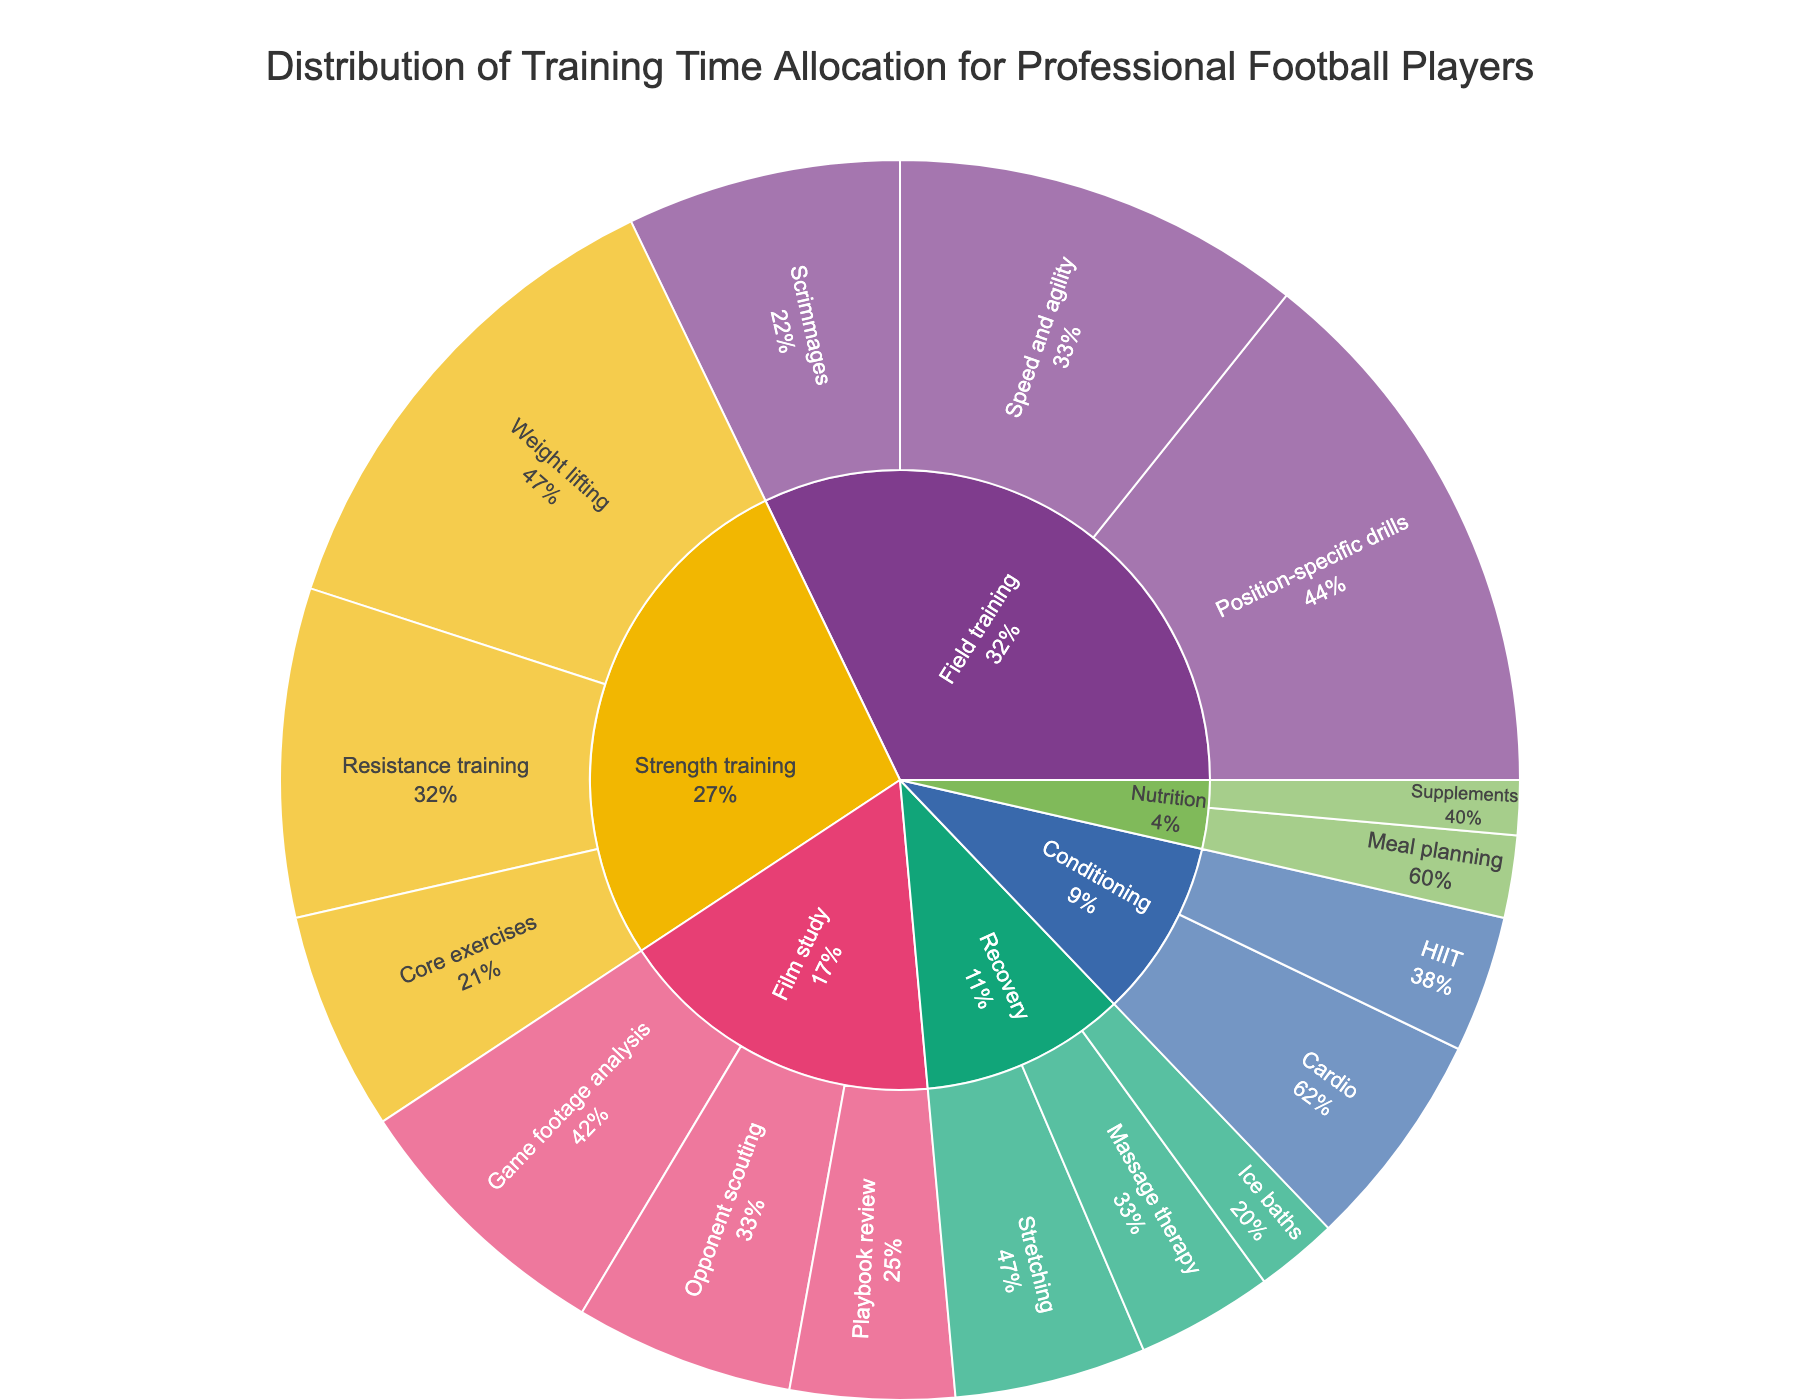What's the largest category in the sunburst plot? Look for the category with the highest summed value. Field training has three subcategories summing up to 45.
Answer: Field training How much time is allocated to Strength training? Add the values of Weight lifting, Resistance training, and Core exercises under Strength training: 18 + 12 + 8 = 38.
Answer: 38 Which subcategory has the smallest time allocation? Compare all the subcategories and identify the smallest value. Ice baths have a value of 3.
Answer: Ice baths Which category encompasses the most subcategories? Count the subcategories within each main category. Both Strength training and Film study have three subcategories each.
Answer: Strength training, Film study What percentage of Field training is allocated to Speed and agility? Speed and agility has a value of 15, and Field training sums to 45. Calculate the percentage: (15/45) * 100 = 33.33%.
Answer: 33.33% Which subcategory under Film study has the highest allocation of time? Identify and compare the values for subcategories within Film study. Game footage analysis has a value of 10.
Answer: Game footage analysis Is the allocated time for Nutrition less than Conditioning? Sum the values for both categories: Nutrition (Meal planning + Supplements = 3 + 2 = 5), Conditioning (Cardio + HIIT = 8 + 5 = 13). Clearly, 5 < 13.
Answer: Yes By how much does the time spent on Weight lifting exceed the time spent on Opponent scouting? Compare the values for Weight lifting and Opponent scouting: 18 - 8 = 10.
Answer: 10 What fraction of Strength training is dedicated to Resistance training? Resistance training has a value of 12, and Strength training sums to 38. Calculate the fraction: 12/38.
Answer: 12/38 What is the combined time allocation for Recovery and Nutrition? Sum the values for both categories: Recovery (7 + 5 + 3 = 15), Nutrition (3 + 2 = 5). Total is 15 + 5 = 20.
Answer: 20 